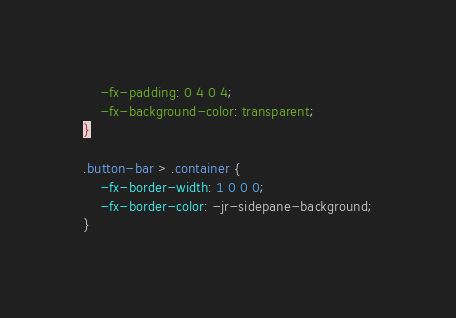<code> <loc_0><loc_0><loc_500><loc_500><_CSS_>    -fx-padding: 0 4 0 4;
    -fx-background-color: transparent;
}

.button-bar > .container {
    -fx-border-width: 1 0 0 0;
    -fx-border-color: -jr-sidepane-background;
}


</code> 